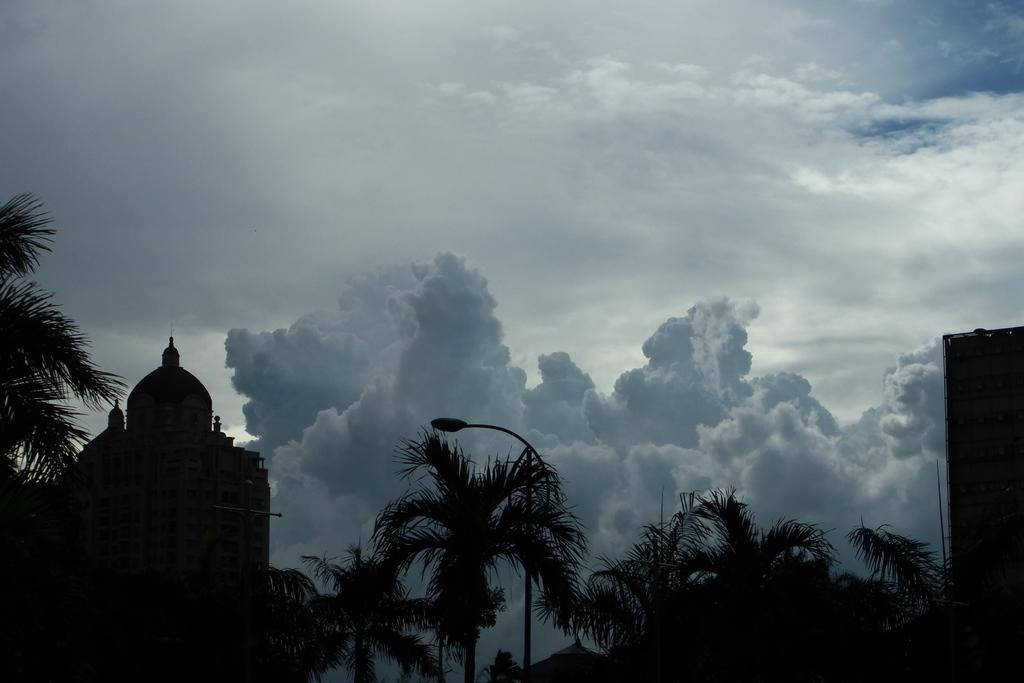What type of vegetation can be seen in the image? There are trees in the image. What artificial light source is visible in the image? There is a street light in the image. What type of structure can be seen in the image? There is a building in the image. What natural phenomena are visible in the sky? There are clouds in the image. What part of the natural environment is visible in the image? The sky is visible in the image. How would you describe the lighting in the image? The image appears to be slightly dark. Can you tell me how many wrens are perched on the street light in the image? There are no wrens present in the image; it only features trees, a street light, a building, clouds, and a slightly dark sky. What type of fowl can be seen walking on the street in the image? There are no fowl or any animals visible in the image; it only features inanimate objects and natural phenomena. 